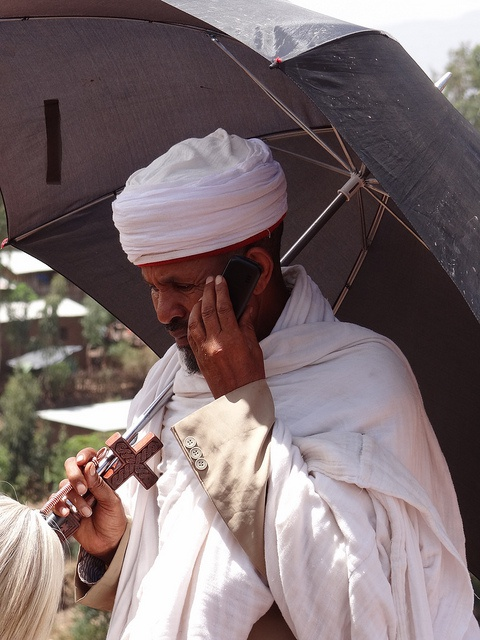Describe the objects in this image and their specific colors. I can see people in brown, darkgray, lightgray, maroon, and black tones, umbrella in brown, black, and gray tones, people in brown, lightgray, gray, and tan tones, and cell phone in black, maroon, and brown tones in this image. 